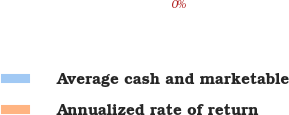Convert chart. <chart><loc_0><loc_0><loc_500><loc_500><pie_chart><fcel>Average cash and marketable<fcel>Annualized rate of return<nl><fcel>100.0%<fcel>0.0%<nl></chart> 